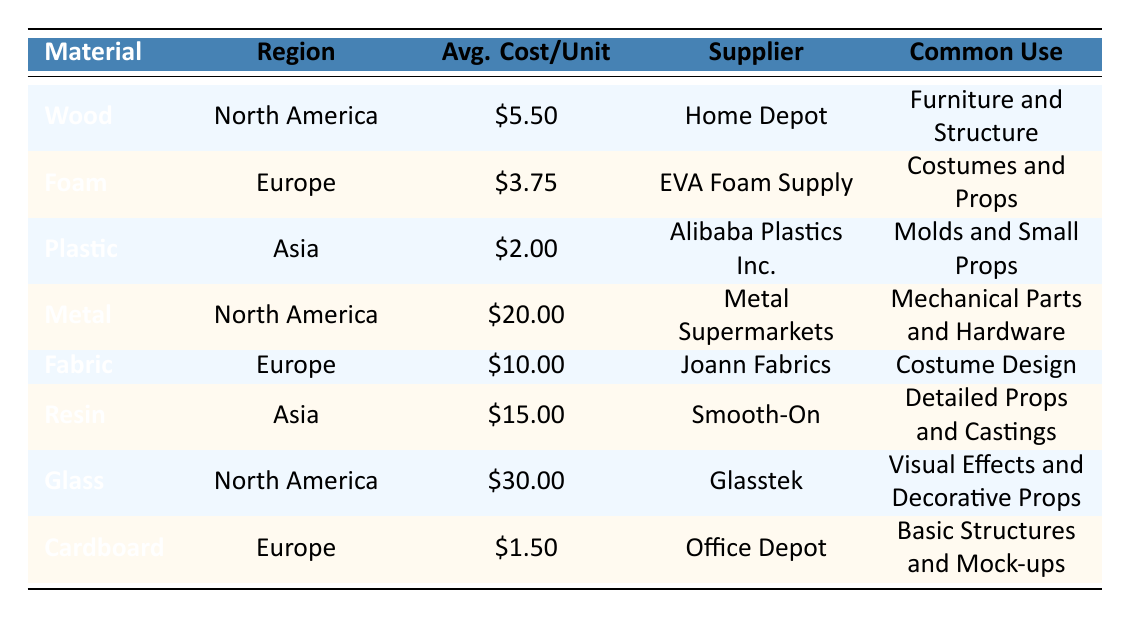What is the average cost per unit of wood in North America? The table shows the average cost per unit of wood in North America as $5.50.
Answer: $5.50 Which material has the highest average cost per unit in North America? By looking at the North America region's materials, glass has the highest average cost per unit at $30.00.
Answer: Glass Is the average cost per unit of cardboard in Europe less than $2.00? The table indicates that the average cost per unit of cardboard in Europe is $1.50, which is less than $2.00.
Answer: Yes What is the total average cost per unit of all materials listed for Europe? The average costs for Europe are foam ($3.75), fabric ($10.00), and cardboard ($1.50). Totaling them gives $3.75 + $10.00 + $1.50 = $15.25.
Answer: $15.25 Does plastic have a higher average cost per unit than foam? The average cost per unit for plastic is $2.00 and for foam it is $3.75. Since $2.00 is less than $3.75, plastic does not.
Answer: No In which region is resin the most expensive material? Resin is listed for the Asia region with an average cost of $15.00, but comparing it to other materials in Asia confirms it's the most expensive in that region.
Answer: Asia What is the difference in average cost per unit between the most expensive and least expensive material? The most expensive material is glass at $30.00 and the least expensive is plastic at $2.00. The difference is calculated as $30.00 - $2.00 = $28.00.
Answer: $28.00 Which supplier provides the material with the lowest cost per unit? The table shows that Office Depot supplies cardboard, the material with the lowest average cost per unit at $1.50.
Answer: Office Depot What is the most common use for metal material? According to the table, the most common use for metal is "Mechanical Parts and Hardware."
Answer: Mechanical Parts and Hardware 